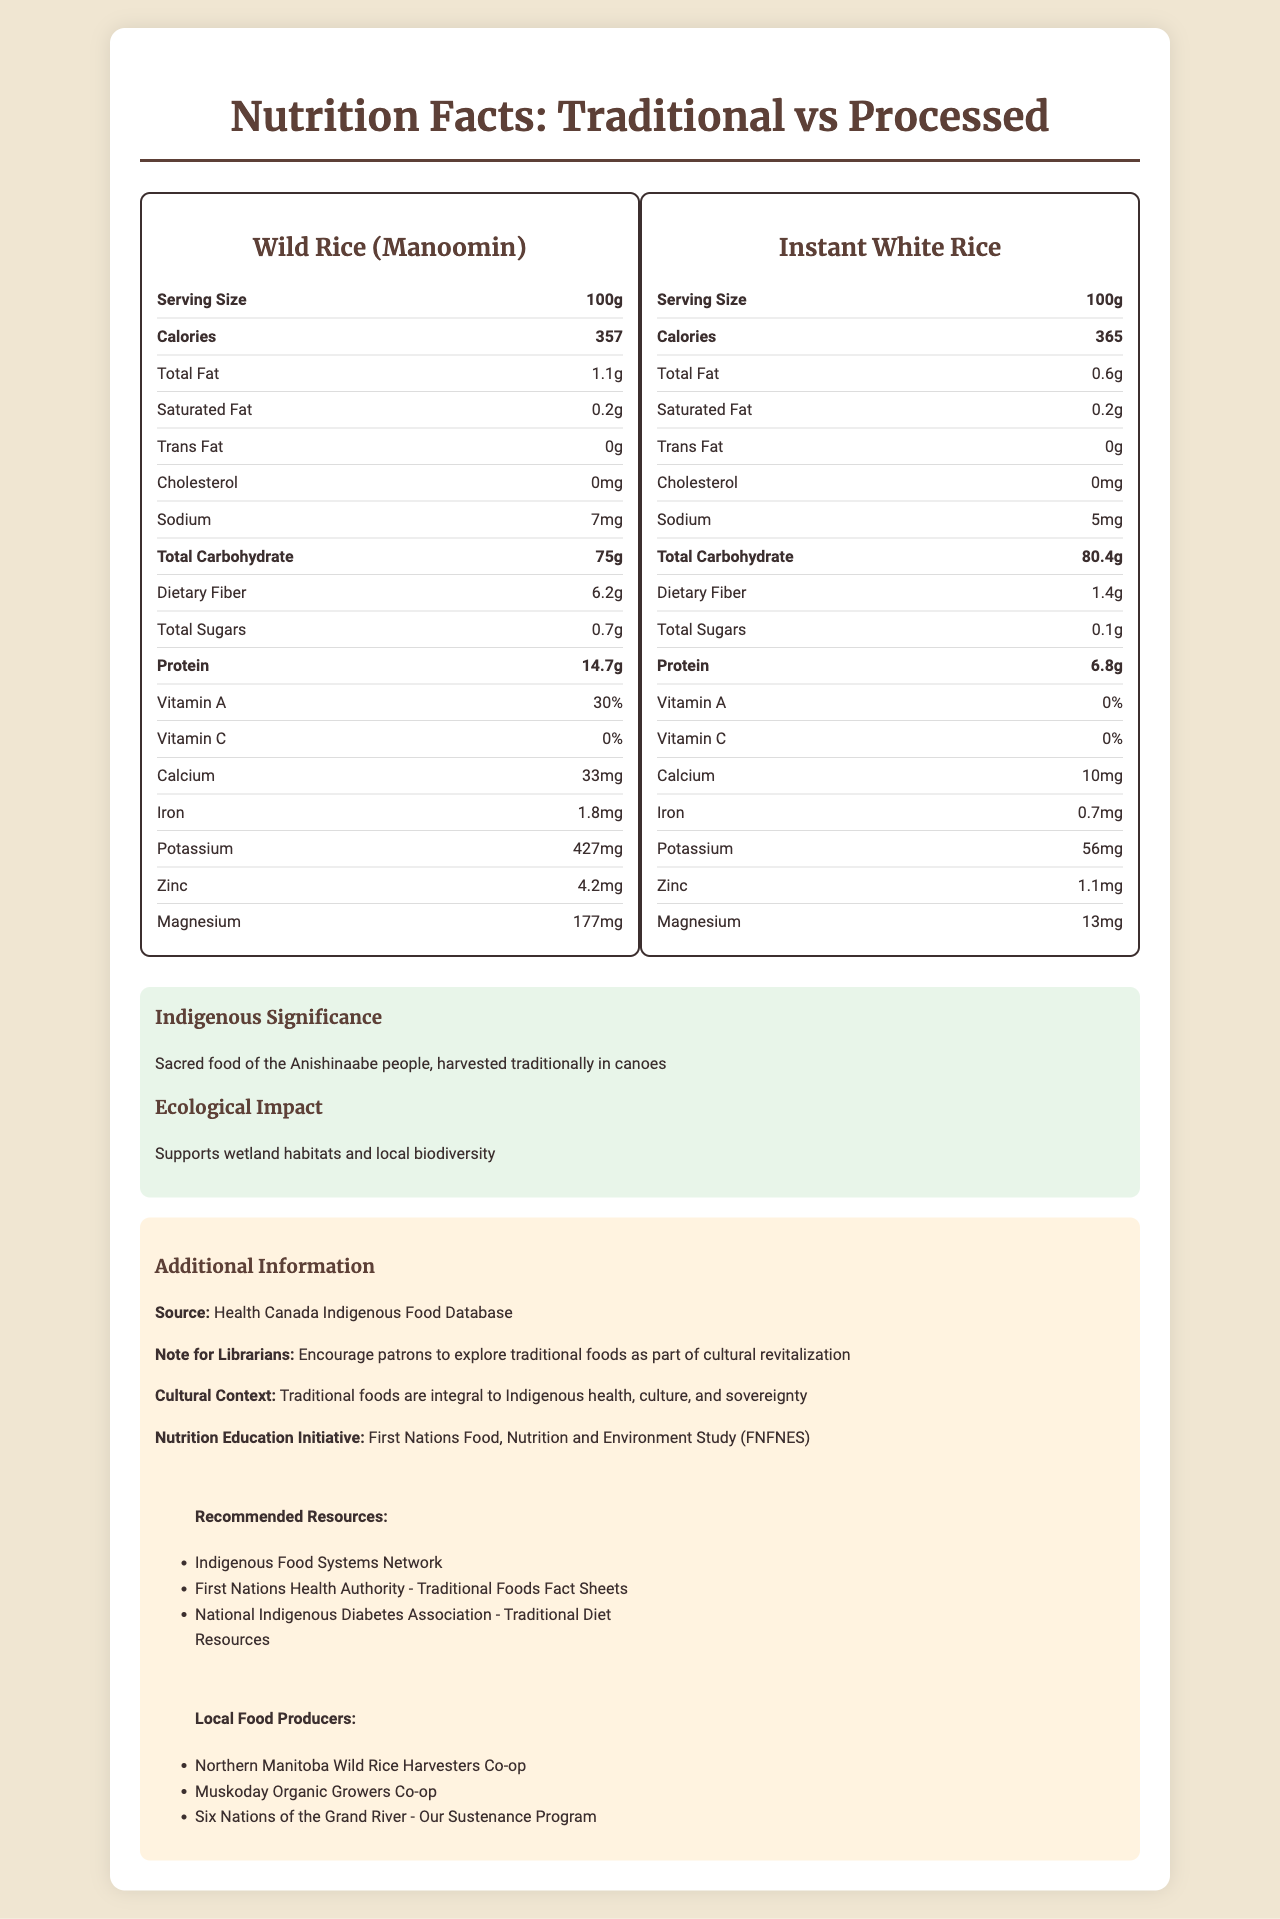what is the serving size for Wild Rice (Manoomin)? The serving size for Wild Rice (Manoomin) is specified as 100g in the nutrition label.
Answer: 100g what is the amount of sodium in Instant White Rice? The nutrition label for Instant White Rice shows that it contains 5mg of sodium.
Answer: 5mg which food has a higher protein content, Wild Rice (Manoomin) or Instant White Rice? Wild Rice (Manoomin) has 14.7g of protein, while Instant White Rice has 6.8g of protein.
Answer: Wild Rice (Manoomin) what is the total carbohydrate content in Instant White Rice? The label indicates that Instant White Rice has a total carbohydrate content of 80.4g.
Answer: 80.4g how does the dietary fiber content of Wild Rice (Manoomin) compare to Instant White Rice? Wild Rice (Manoomin) contains 6.2g of dietary fiber compared to Instant White Rice's 1.4g.
Answer: Wild Rice (Manoomin) has significantly more dietary fiber. what significance does Wild Rice (Manoomin) have to the Anishinaabe people? According to the document, Wild Rice (Manoomin) is a sacred food of the Anishinaabe people and is harvested traditionally in canoes.
Answer: Sacred food, harvested traditionally in canoes what environmental impact is mentioned for Instant White Rice? A. Supports biodiversity B. Higher carbon footprint C. No impact D. Reduces wetland habitats The document states that Instant White Rice has a higher carbon footprint due to processing and packaging.
Answer: B. Higher carbon footprint which food has a higher iron content, Wild Rice (Manoomin) or Instant White Rice? A. Wild Rice (Manoomin) B. Instant White Rice C. Both have the same D. Not mentioned Wild Rice (Manoomin) contains 1.8mg of iron, compared to Instant White Rice's 0.7mg.
Answer: A. Wild Rice (Manoomin) is the vitamin C content in Wild Rice (Manoomin) higher than Instant White Rice? Based on the nutrition labels, both Wild Rice (Manoomin) and Instant White Rice have 0% vitamin C content.
Answer: No summarize the main idea of the document. The document provides a comprehensive comparison and valuable information aimed at encouraging the exploration and consumption of traditional Indigenous foods like Wild Rice (Manoomin), emphasizing their health, cultural, and environmental benefits.
Answer: The document compares the nutritional facts, indigenous significance, and ecological impacts of Wild Rice (Manoomin), a traditional Indigenous food, with Instant White Rice, a processed alternative. It highlights the nutritional superiority and cultural importance of Wild Rice (Manoomin) for the Anishinaabe people, along with its lower ecological footprint. Additionally, it provides resources for exploring traditional foods and emphasizes the need for cultural revitalization and health improvement through the consumption of traditional foods. what are the sources of this nutrition information? The document states that the source of the nutrition information is the Health Canada Indigenous Food Database.
Answer: Health Canada Indigenous Food Database list two recommended resources provided in the document. The document lists multiple recommended resources, including the Indigenous Food Systems Network and the First Nations Health Authority - Traditional Foods Fact Sheets.
Answer: Indigenous Food Systems Network, First Nations Health Authority - Traditional Foods Fact Sheets how much magnesium does Instant White Rice contain? According to the nutrition label, Instant White Rice contains 13mg of magnesium.
Answer: 13mg what is the ecological impact of Wild Rice (Manoomin)? The document mentions that Wild Rice (Manoomin) supports wetland habitats and local biodiversity.
Answer: Supports wetland habitats and local biodiversity what is the processing method used for Instant White Rice? The food label mentions that Instant White Rice is precooked and dehydrated for quick preparation.
Answer: Precooked and dehydrated for quick preparation what indigenous food is sacred to the Cree people? The document specifically mentions the Anishinaabe people and does not provide information about the Cree people's sacred foods.
Answer: Cannot be determined 